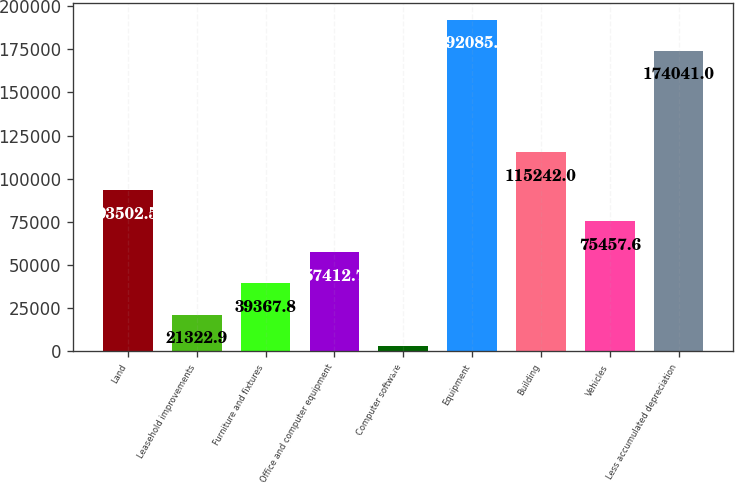<chart> <loc_0><loc_0><loc_500><loc_500><bar_chart><fcel>Land<fcel>Leasehold improvements<fcel>Furniture and fixtures<fcel>Office and computer equipment<fcel>Computer software<fcel>Equipment<fcel>Building<fcel>Vehicles<fcel>Less accumulated depreciation<nl><fcel>93502.5<fcel>21322.9<fcel>39367.8<fcel>57412.7<fcel>3278<fcel>192086<fcel>115242<fcel>75457.6<fcel>174041<nl></chart> 